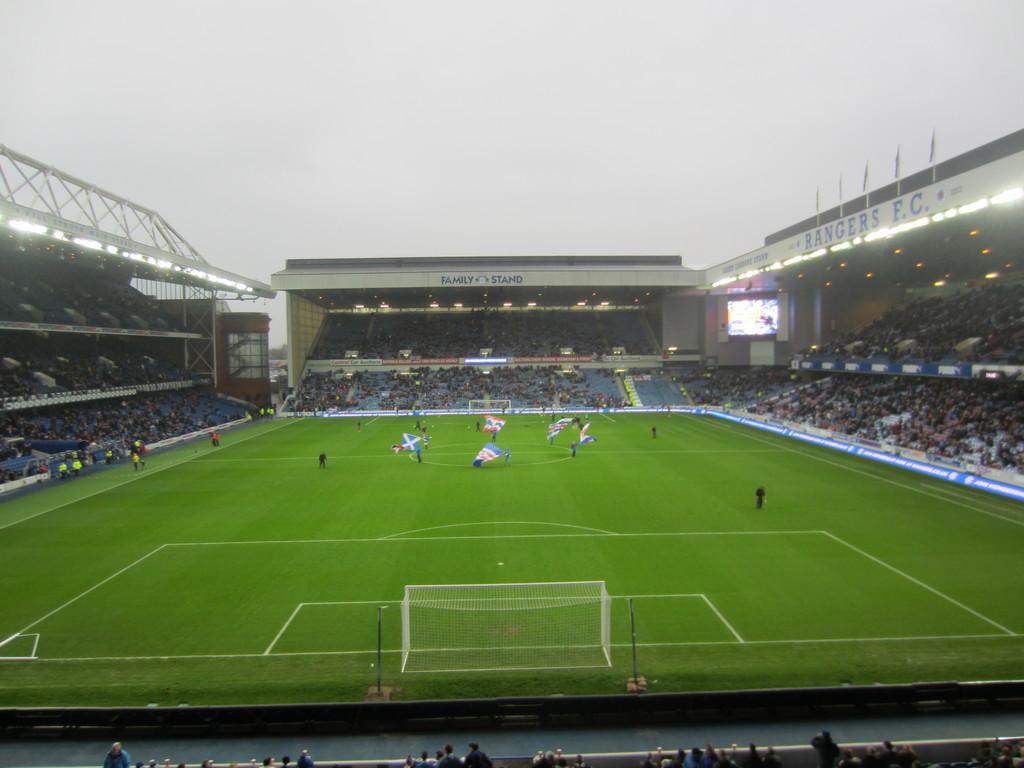What stand is the middle one?
Ensure brevity in your answer.  Unanswerable. What is the name of the stafium?
Your answer should be compact. Unanswerable. 